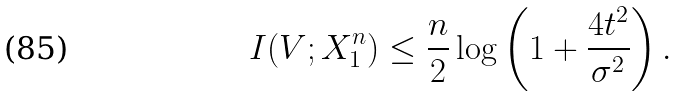Convert formula to latex. <formula><loc_0><loc_0><loc_500><loc_500>I ( V ; X _ { 1 } ^ { n } ) \leq \frac { n } { 2 } \log \left ( 1 + \frac { 4 t ^ { 2 } } { \sigma ^ { 2 } } \right ) .</formula> 